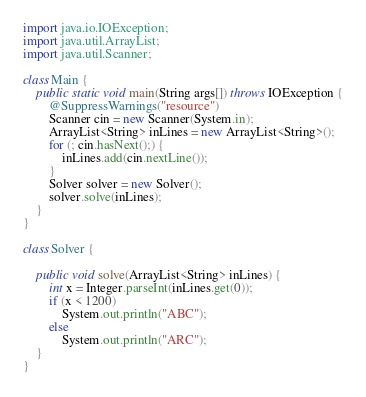Convert code to text. <code><loc_0><loc_0><loc_500><loc_500><_Java_>import java.io.IOException;
import java.util.ArrayList;
import java.util.Scanner;

class Main {
	public static void main(String args[]) throws IOException {
		@SuppressWarnings("resource")
		Scanner cin = new Scanner(System.in);
		ArrayList<String> inLines = new ArrayList<String>();
		for (; cin.hasNext();) {
			inLines.add(cin.nextLine());
		}
		Solver solver = new Solver();
		solver.solve(inLines);
	}
}

class Solver {

	public void solve(ArrayList<String> inLines) {
		int x = Integer.parseInt(inLines.get(0));
		if (x < 1200)
			System.out.println("ABC");
		else
			System.out.println("ARC");
	}
}
</code> 